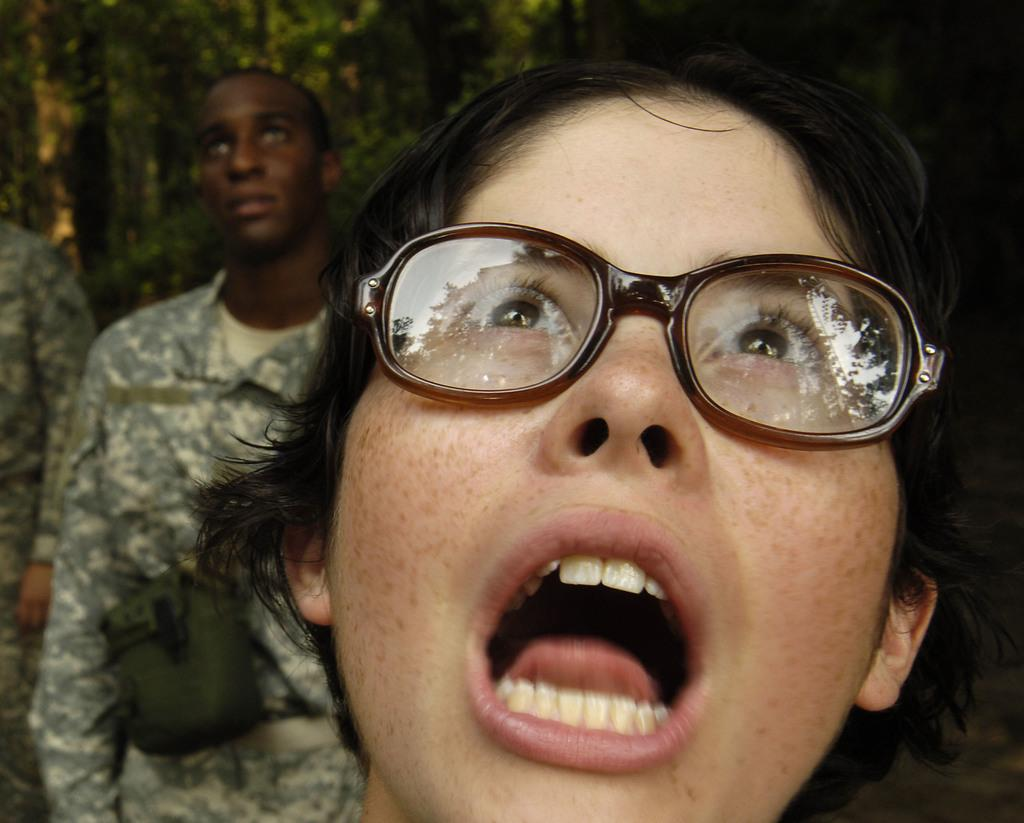What is the person in the foreground of the image wearing? The person in the foreground of the image is wearing spectacles. What can be seen in the background of the image? There are people standing in the background of the image. What type of environment is visible in the image? There is greenery visible in the image. What type of pollution is visible in the image? There is no visible pollution in the image; it features a person wearing spectacles and greenery in the background. What type of store can be seen in the image? There is no store present in the image. 